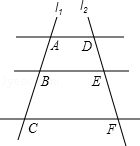Could you explain any real-world applications of such a diagram? Certainly! Diagrams like this one are fundamental in understanding the principles of geometry that apply to many real-world scenarios. For instance, understanding intersecting lines and angles is crucial in fields like architecture, engineering, and even navigation. For example, in urban planning, the layout of roads often involves creating grids or patterns where understanding the relationships between different lines is vital. 